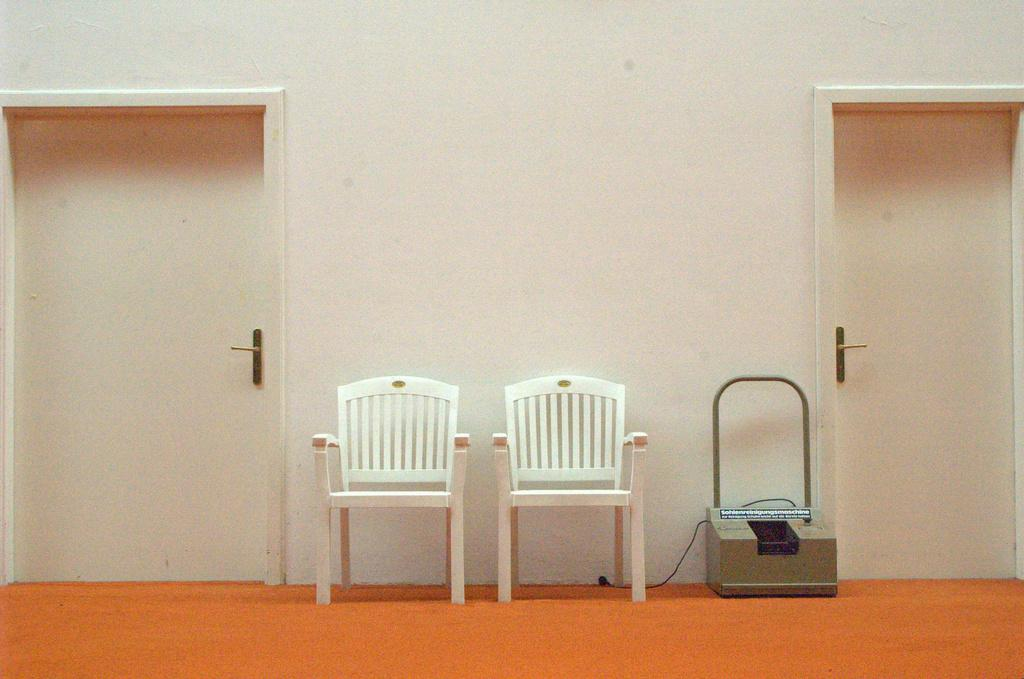Where was the image taken? The image was taken inside a building. What furniture can be seen in the front of the image? There are two chairs in the front of the image. What architectural feature is present in the front of the image? There are doors in the front of the image. What color is the floor mat at the bottom of the image? The floor mat is orange in color. What type of object is located beside the door? There is a machine beside the door. What type of pie is being sold in the shop in the image? There is no shop or pie present in the image; it is taken inside a building with chairs, doors, an orange floor mat, and a machine beside the door. 